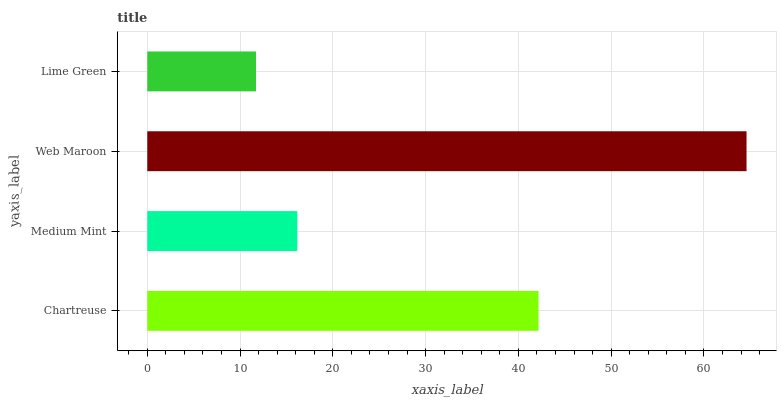Is Lime Green the minimum?
Answer yes or no. Yes. Is Web Maroon the maximum?
Answer yes or no. Yes. Is Medium Mint the minimum?
Answer yes or no. No. Is Medium Mint the maximum?
Answer yes or no. No. Is Chartreuse greater than Medium Mint?
Answer yes or no. Yes. Is Medium Mint less than Chartreuse?
Answer yes or no. Yes. Is Medium Mint greater than Chartreuse?
Answer yes or no. No. Is Chartreuse less than Medium Mint?
Answer yes or no. No. Is Chartreuse the high median?
Answer yes or no. Yes. Is Medium Mint the low median?
Answer yes or no. Yes. Is Web Maroon the high median?
Answer yes or no. No. Is Chartreuse the low median?
Answer yes or no. No. 